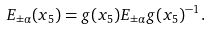<formula> <loc_0><loc_0><loc_500><loc_500>E _ { \pm \alpha } ( x _ { 5 } ) = g ( x _ { 5 } ) E _ { \pm \alpha } g ( x _ { 5 } ) ^ { - 1 } .</formula> 